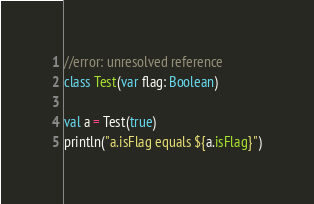Convert code to text. <code><loc_0><loc_0><loc_500><loc_500><_Kotlin_>//error: unresolved reference
class Test(var flag: Boolean)

val a = Test(true)
println("a.isFlag equals ${a.isFlag}")</code> 